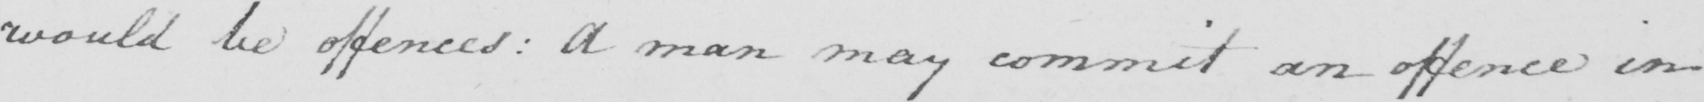What text is written in this handwritten line? would be offences: A man may commit an offence in 